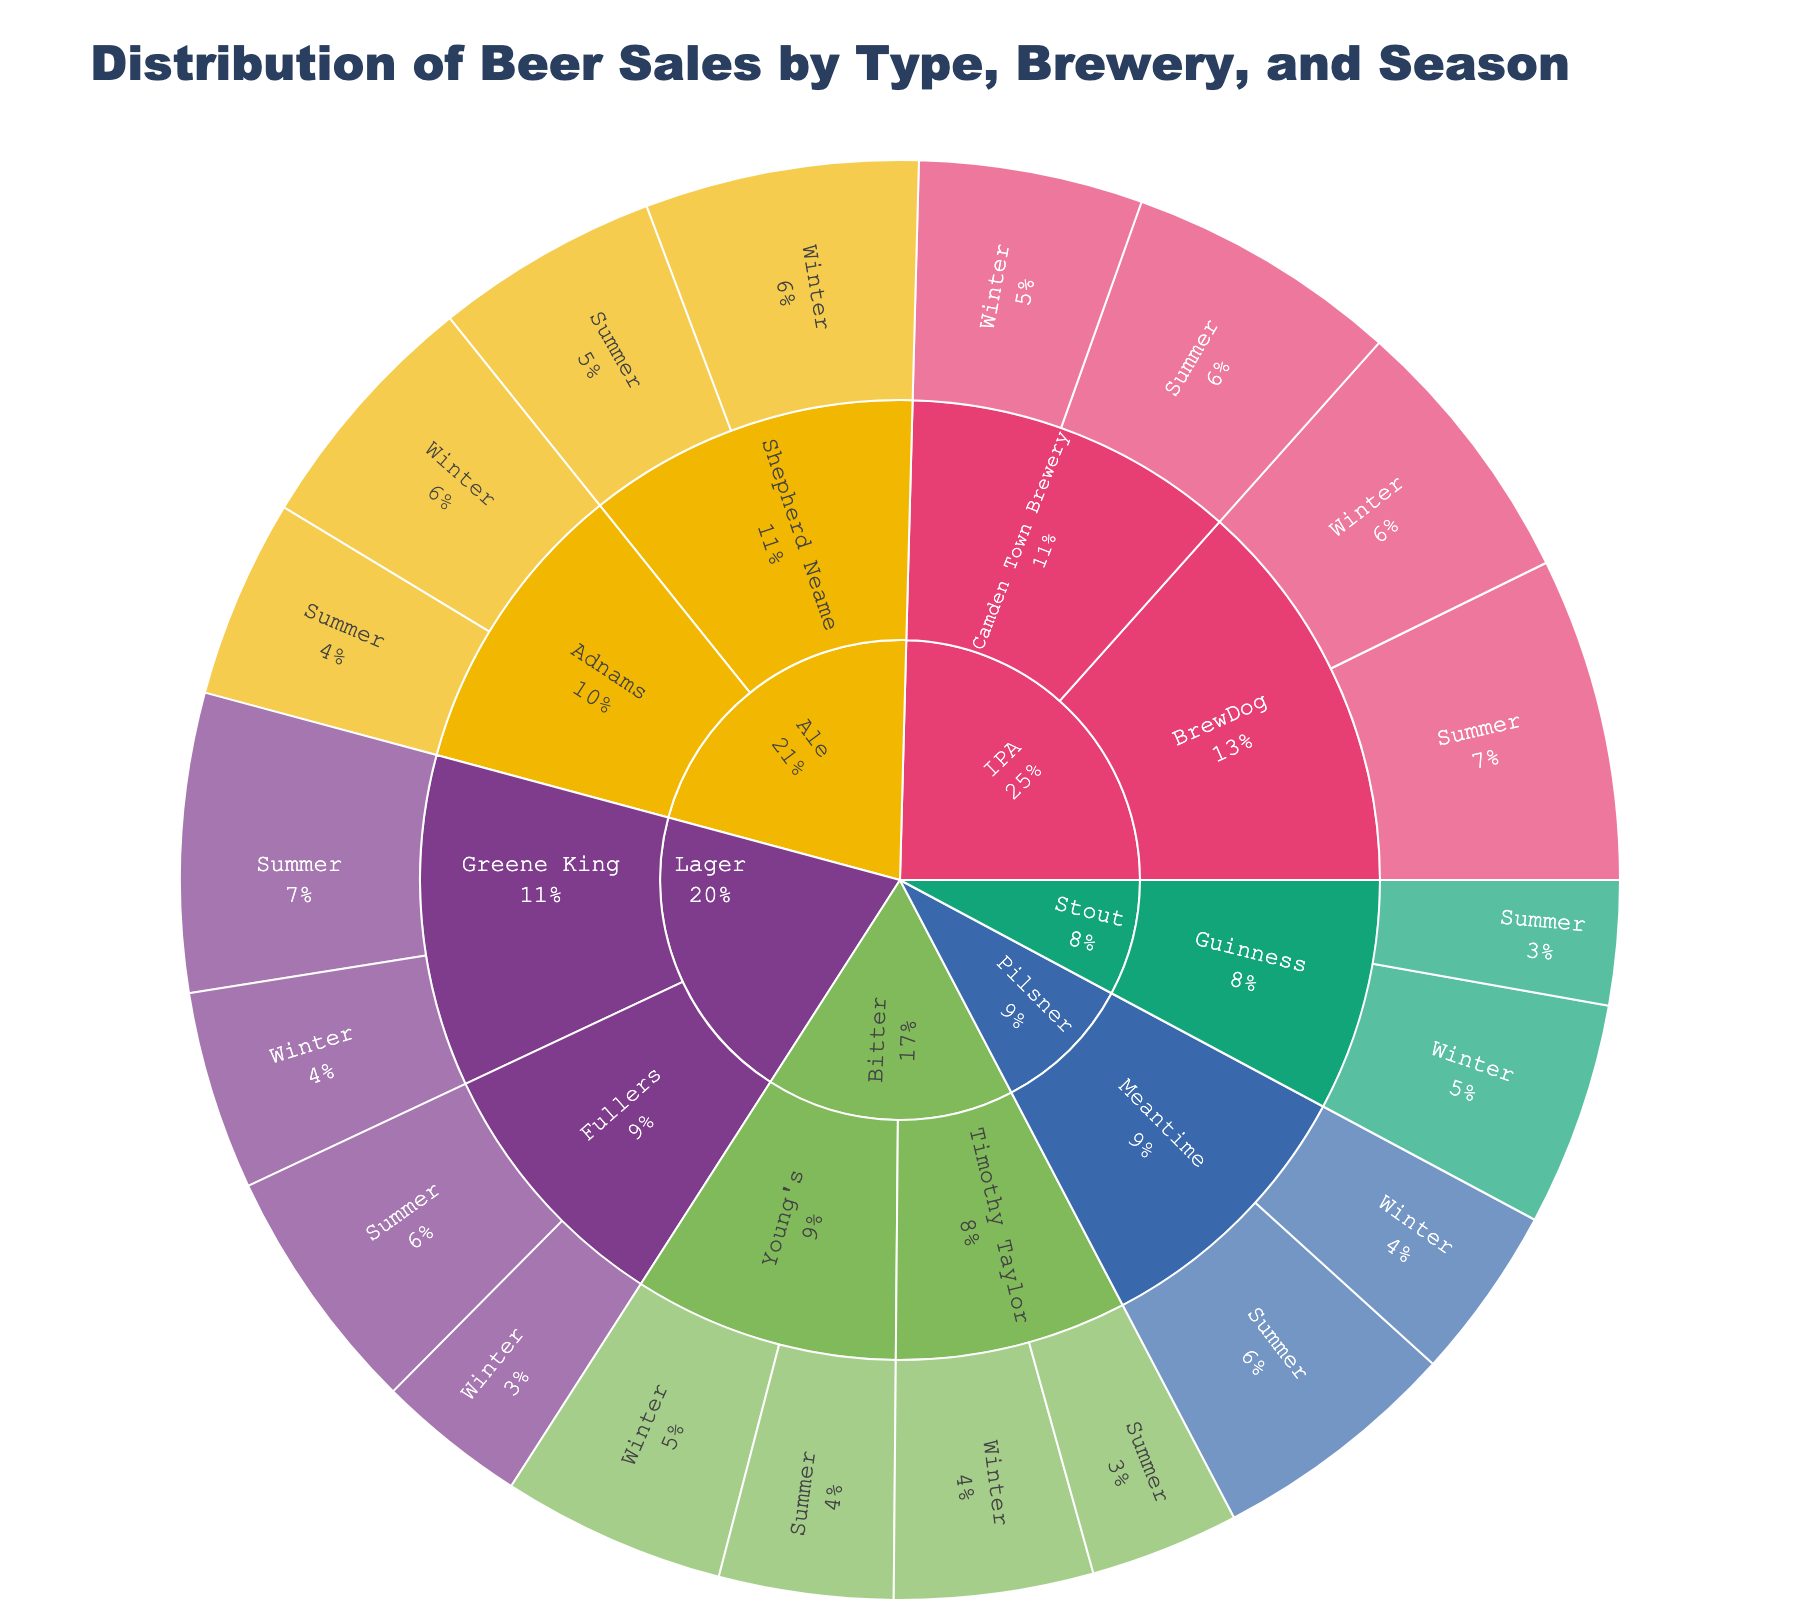what is the title of the plot? The title is usually found at the top of the plot and often describes what the plot is about. Looking at the very top, you can see the label "Distribution of Beer Sales by Type, Brewery, and Season".
Answer: Distribution of Beer Sales by Type, Brewery, and Season Which beer type has the highest sales in summer? To answer this, locate the segment that represents the beer type with the highest sales in the summer season. Sum of sales for each type: Lager (Greene King: 1200 + Fullers: 1000), Ale (Shepherd Neame: 900 + Adnams: 800), Stout (Guinness: 500), IPA (BrewDog: 1300 + Camden Town Brewery: 1100), Bitter (Young's: 700 + Timothy Taylor: 600), Pilsner (Meantime: 1000). IPA has the highest sum of summer sales at 2400.
Answer: IPA What's the total sales of Ale beer in winter? First, identify the Ale segments and sum their winter sales values. For Shepherd Neame, the sales are 1100, and for Adnams, the sales are 1000. Summing them up gives us: 1100 + 1000.
Answer: 2100 Which brewery sells the most IPA beer in summer? Navigate to the IPA beer outer ring during the summer season and compare the sales numbers of BrewDog and Camden Town Brewery. BrewDog has 1300, and Camden Town Brewery has 1100.
Answer: BrewDog How does the winter sales of Pilsner compare to the summer sales of Bitter? To compare, find the winter sales value of Pilsner, which is 700, and the summer sales value of Bitter, which is the sum of Young's and Timothy Taylor, 700 + 600. Compare: 700 (Pilsner in winter) vs. 1300 (Bitter in summer).
Answer: Winter sales of Pilsner are less than summer sales of Bitter Which season has higher sales for Lager beer at Greene King? Navigate to Lager beer at Greene King and compare the sales numbers in summer (1200) and winter (800).
Answer: Summer Compare the summer sales of Fullers Lager beer to the winter sales of Guinness Stout. Identifying summer value for Fullers Lager beer is 1000, and winter value for Guinness Stout is 900. Compare these two numbers: 1000 > 900.
Answer: Fuller’s Lager beer has higher summer sales than Guinness Stout's winter sales Which brewery has the least total sales in the data? Calculate the total sales for all seasons and all types for each brewery and compare. Young's (700 + 900), Timothy Taylor (600 + 800), Meantime (1000 + 700), Camden Town Brewery (1100 + 900), BrewDog (1300 + 1100), Guinness (500 + 900), Adnams (800 + 1000), Shepherd Neame (900 + 1100), Fullers (1000 + 600), Green King (1200 + 900). Timothy Taylor has the lowest total sales (1400).
Answer: Timothy Taylor 